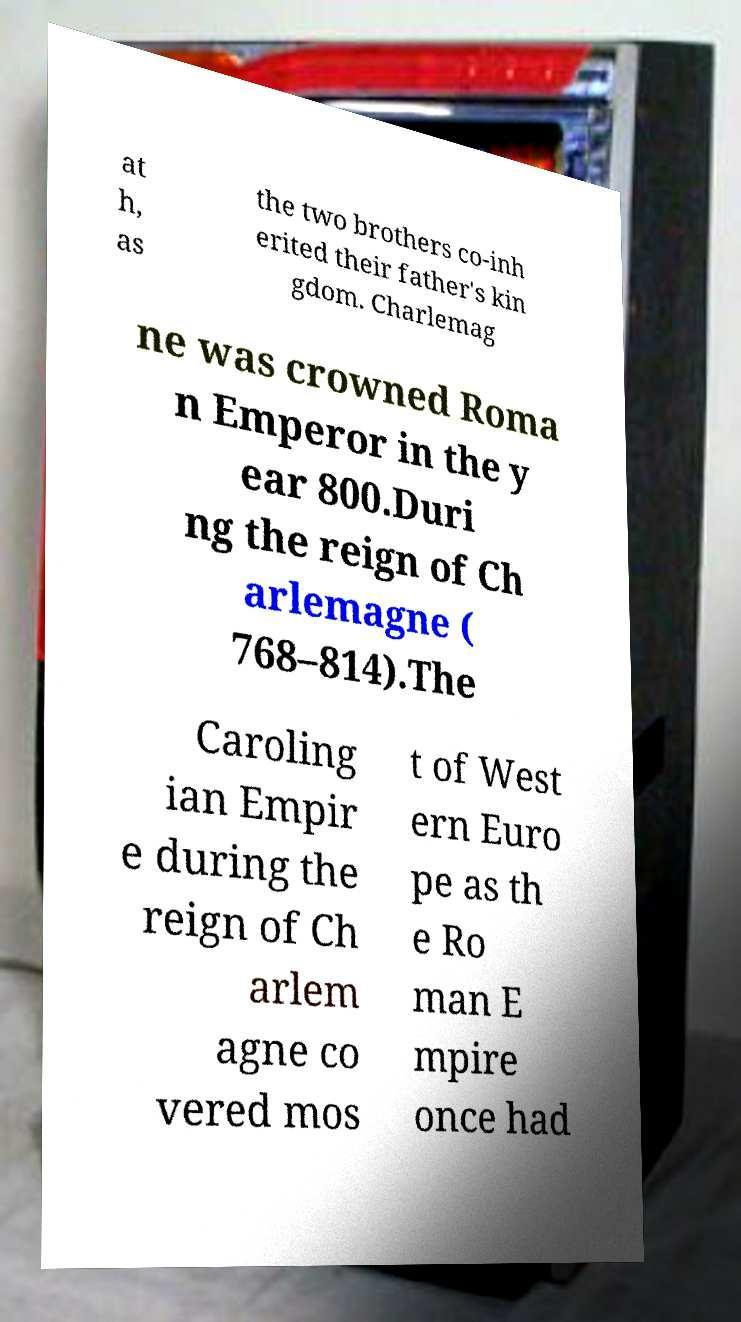Can you accurately transcribe the text from the provided image for me? at h, as the two brothers co-inh erited their father's kin gdom. Charlemag ne was crowned Roma n Emperor in the y ear 800.Duri ng the reign of Ch arlemagne ( 768–814).The Caroling ian Empir e during the reign of Ch arlem agne co vered mos t of West ern Euro pe as th e Ro man E mpire once had 